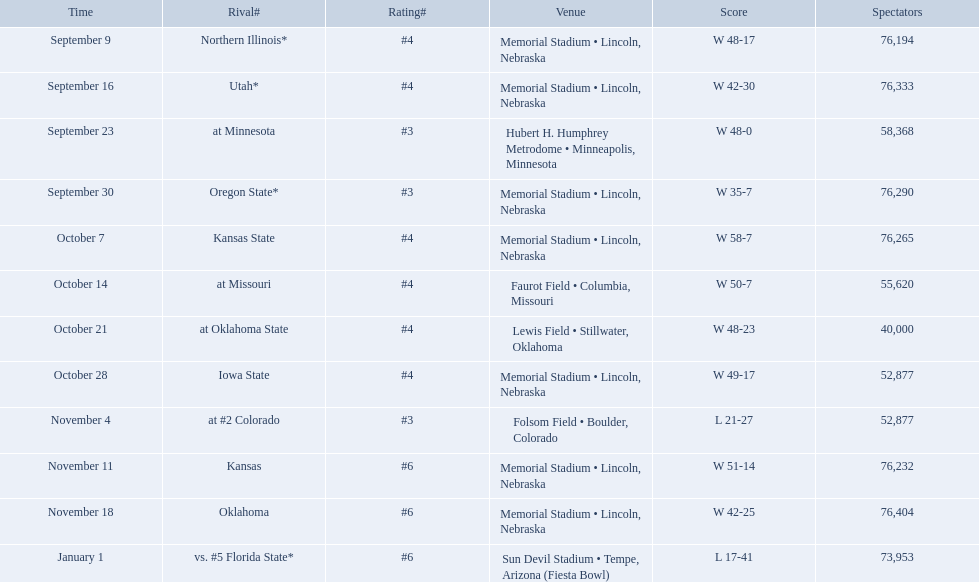Which opponenets did the nebraska cornhuskers score fewer than 40 points against? Oregon State*, at #2 Colorado, vs. #5 Florida State*. Of these games, which ones had an attendance of greater than 70,000? Oregon State*, vs. #5 Florida State*. Which of these opponents did they beat? Oregon State*. How many people were in attendance at that game? 76,290. 